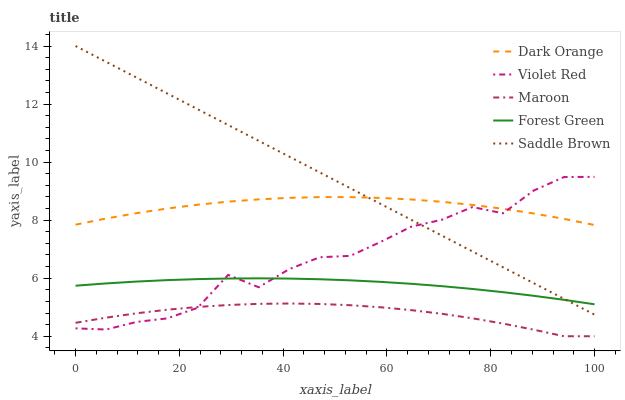Does Maroon have the minimum area under the curve?
Answer yes or no. Yes. Does Saddle Brown have the maximum area under the curve?
Answer yes or no. Yes. Does Violet Red have the minimum area under the curve?
Answer yes or no. No. Does Violet Red have the maximum area under the curve?
Answer yes or no. No. Is Saddle Brown the smoothest?
Answer yes or no. Yes. Is Violet Red the roughest?
Answer yes or no. Yes. Is Forest Green the smoothest?
Answer yes or no. No. Is Forest Green the roughest?
Answer yes or no. No. Does Maroon have the lowest value?
Answer yes or no. Yes. Does Violet Red have the lowest value?
Answer yes or no. No. Does Saddle Brown have the highest value?
Answer yes or no. Yes. Does Violet Red have the highest value?
Answer yes or no. No. Is Maroon less than Saddle Brown?
Answer yes or no. Yes. Is Dark Orange greater than Forest Green?
Answer yes or no. Yes. Does Forest Green intersect Violet Red?
Answer yes or no. Yes. Is Forest Green less than Violet Red?
Answer yes or no. No. Is Forest Green greater than Violet Red?
Answer yes or no. No. Does Maroon intersect Saddle Brown?
Answer yes or no. No. 